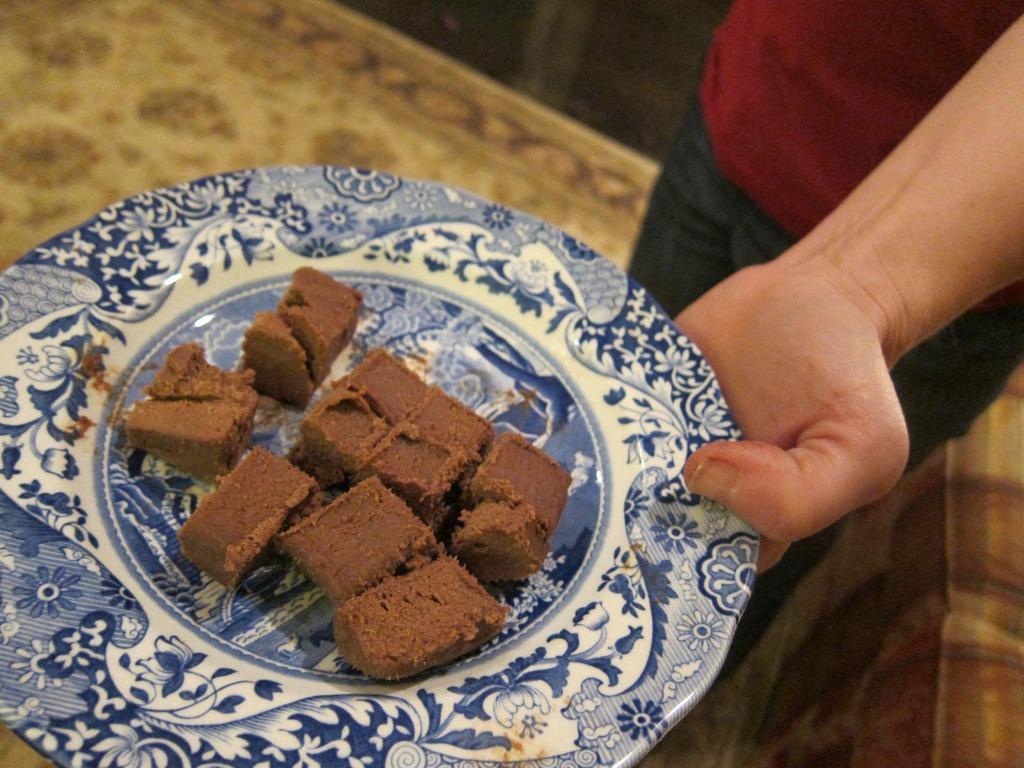Describe this image in one or two sentences. In this image we can see a person wearing a red t shirt is holding a plate in his hand containing food is standing on the floor. 